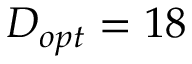Convert formula to latex. <formula><loc_0><loc_0><loc_500><loc_500>D _ { o p t } = 1 8</formula> 